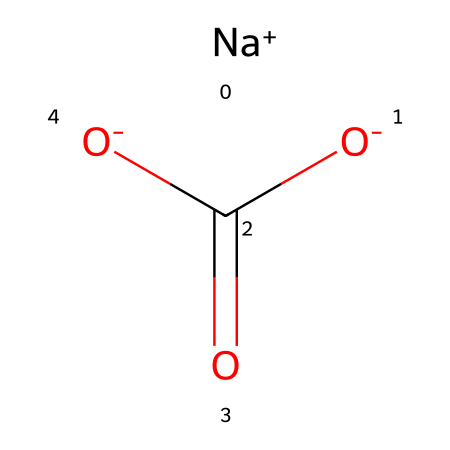What is the molecular formula of sodium bicarbonate? The SMILES representation shows sodium (Na+), two oxygen (O-) in carboxylate form, and one carbon (C) along with one additional oxygen part of the carbonyl group (O=). Therefore, the molecular formula can be deduced as NaHCO3.
Answer: NaHCO3 How many oxygen atoms are in sodium bicarbonate? From the SMILES representation, there are three oxygen atoms present when considering one in the carbonyl (O=) and two in the carboxylate (O-).
Answer: three What type of ion is sodium in sodium bicarbonate? The representation indicates sodium as a positive ion (Na+), which defines its character as a cation.
Answer: cation What is the primary functional group in sodium bicarbonate? The carboxylate group (-COO-) is indicated in the structure, representing the primary functional group present in sodium bicarbonate.
Answer: carboxylate What role does the bicarbonate play in dental care for dogs? The bicarbonate acts as a mild abrasive and helps neutralize acidity, which aids in cleaning teeth and maintaining oral pH.
Answer: abrasive How many total atoms are present in sodium bicarbonate? In the structure, there are one sodium, one carbon, three oxygens, and one hydrogen, totaling six atoms in sodium bicarbonate.
Answer: six 